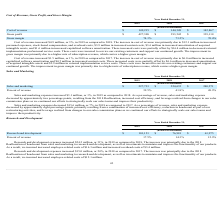According to Cornerstone Ondemand's financial document, Why did research and development expenses increase between 2018 and 2019? The increase was principally due to the 2018 Reallocation of headcount from sales and marketing to research and development, as well as investments. The document states: "4.2 million, or 31%, in 2019 as compared to 2018. The increase was principally due to the 2018 Reallocation of headcount from sales and marketing to r..." Also, How much were employee-related costs between 2017 and 2018? According to the financial document, $12.1 million. The relevant text states: "e increase in cost of revenue was primarily due to $12.1 million in increased..." Also, What was the percentage of revenue of research and development in 2018? According to the financial document, 14.3%. The relevant text states: "Percent of revenue 17.5% 14.3% 12.9%..." Also, can you calculate: What was the change in percentage of revenue of research and development between 2017 and 2018? Based on the calculation: (14.3%-12.9%), the result is 1.4 (percentage). This is based on the information: "Percent of revenue 17.5% 14.3% 12.9% Percent of revenue 17.5% 14.3% 12.9%..." The key data points involved are: 12.9, 14.3. Also, can you calculate: What is the average year-on-year increase in Research and development from 2017 to 2019? To answer this question, I need to perform calculations using the financial data. The calculation is: (($101,151-$76,981)/$76,981+($76,981-$61,975)/$61,975)/2, which equals 27.81 (percentage). This is based on the information: "Research and development $ 101,151 $ 76,981 $ 61,975 Research and development $ 101,151 $ 76,981 $ 61,975 Research and development $ 101,151 $ 76,981 $ 61,975..." The key data points involved are: 101,151, 61,975, 76,981. Also, can you calculate: What was the average research and development from 2017-2019? To answer this question, I need to perform calculations using the financial data. The calculation is: ($101,151+$76,981+$61,975)/(2019-2017+1), which equals 80035.67 (in thousands). This is based on the information: "Research and development $ 101,151 $ 76,981 $ 61,975 Research and development $ 101,151 $ 76,981 $ 61,975 Research and development $ 101,151 $ 76,981 $ 61,975..." The key data points involved are: 101,151, 61,975, 76,981. 